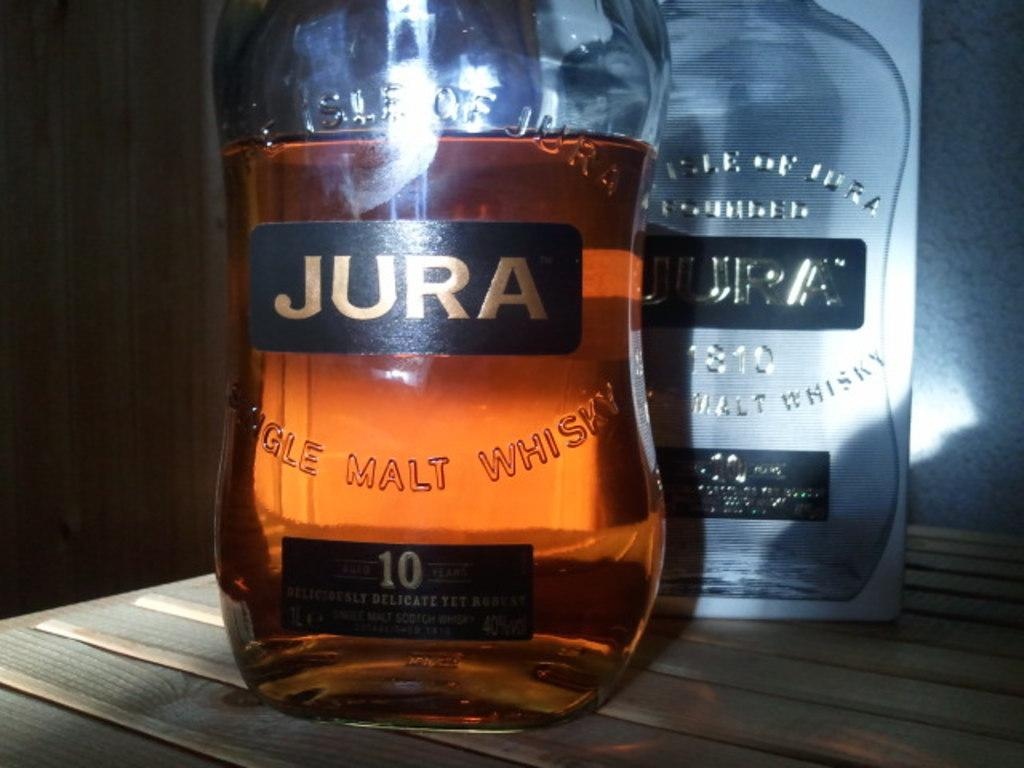What is the main object in the image? There is a whiskey bottle in the image. Can you describe any specific features of the whiskey bottle? The whiskey bottle has a label on it. What type of pancake is being served on the neck of the whiskey bottle in the image? There is no pancake present in the image, nor is there any indication of a neck on the whiskey bottle. 